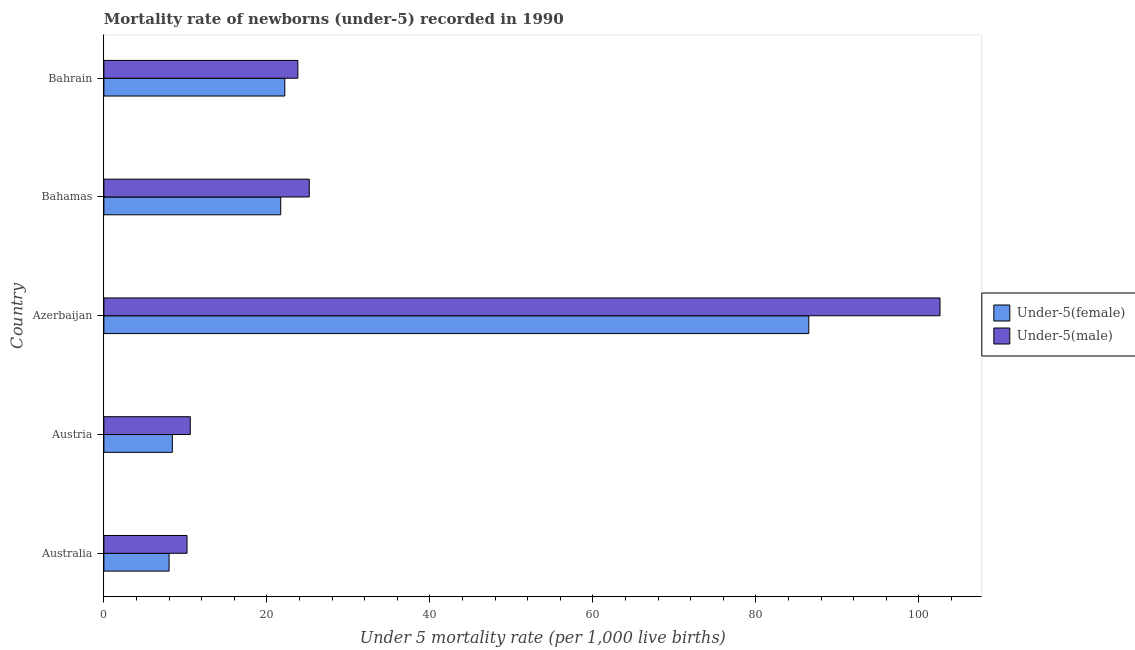How many groups of bars are there?
Provide a succinct answer. 5. Are the number of bars on each tick of the Y-axis equal?
Provide a succinct answer. Yes. How many bars are there on the 5th tick from the top?
Offer a very short reply. 2. How many bars are there on the 5th tick from the bottom?
Your answer should be very brief. 2. What is the label of the 1st group of bars from the top?
Ensure brevity in your answer.  Bahrain. In how many cases, is the number of bars for a given country not equal to the number of legend labels?
Offer a terse response. 0. What is the under-5 male mortality rate in Austria?
Ensure brevity in your answer.  10.6. Across all countries, what is the maximum under-5 female mortality rate?
Give a very brief answer. 86.5. In which country was the under-5 male mortality rate maximum?
Provide a short and direct response. Azerbaijan. In which country was the under-5 female mortality rate minimum?
Your response must be concise. Australia. What is the total under-5 male mortality rate in the graph?
Ensure brevity in your answer.  172.4. What is the difference between the under-5 male mortality rate in Austria and that in Bahamas?
Give a very brief answer. -14.6. What is the average under-5 male mortality rate per country?
Ensure brevity in your answer.  34.48. What is the ratio of the under-5 male mortality rate in Australia to that in Bahamas?
Give a very brief answer. 0.41. Is the difference between the under-5 female mortality rate in Australia and Austria greater than the difference between the under-5 male mortality rate in Australia and Austria?
Ensure brevity in your answer.  No. What is the difference between the highest and the second highest under-5 male mortality rate?
Give a very brief answer. 77.4. What is the difference between the highest and the lowest under-5 female mortality rate?
Keep it short and to the point. 78.5. Is the sum of the under-5 female mortality rate in Australia and Austria greater than the maximum under-5 male mortality rate across all countries?
Provide a succinct answer. No. What does the 2nd bar from the top in Australia represents?
Your answer should be compact. Under-5(female). What does the 2nd bar from the bottom in Bahamas represents?
Make the answer very short. Under-5(male). Are all the bars in the graph horizontal?
Your answer should be very brief. Yes. Does the graph contain any zero values?
Provide a succinct answer. No. Does the graph contain grids?
Ensure brevity in your answer.  No. How many legend labels are there?
Your answer should be very brief. 2. How are the legend labels stacked?
Provide a succinct answer. Vertical. What is the title of the graph?
Make the answer very short. Mortality rate of newborns (under-5) recorded in 1990. Does "Measles" appear as one of the legend labels in the graph?
Keep it short and to the point. No. What is the label or title of the X-axis?
Offer a terse response. Under 5 mortality rate (per 1,0 live births). What is the Under 5 mortality rate (per 1,000 live births) in Under-5(male) in Australia?
Provide a short and direct response. 10.2. What is the Under 5 mortality rate (per 1,000 live births) of Under-5(female) in Austria?
Provide a short and direct response. 8.4. What is the Under 5 mortality rate (per 1,000 live births) of Under-5(male) in Austria?
Give a very brief answer. 10.6. What is the Under 5 mortality rate (per 1,000 live births) of Under-5(female) in Azerbaijan?
Your answer should be compact. 86.5. What is the Under 5 mortality rate (per 1,000 live births) in Under-5(male) in Azerbaijan?
Provide a short and direct response. 102.6. What is the Under 5 mortality rate (per 1,000 live births) of Under-5(female) in Bahamas?
Keep it short and to the point. 21.7. What is the Under 5 mortality rate (per 1,000 live births) in Under-5(male) in Bahamas?
Provide a succinct answer. 25.2. What is the Under 5 mortality rate (per 1,000 live births) of Under-5(female) in Bahrain?
Offer a terse response. 22.2. What is the Under 5 mortality rate (per 1,000 live births) of Under-5(male) in Bahrain?
Make the answer very short. 23.8. Across all countries, what is the maximum Under 5 mortality rate (per 1,000 live births) of Under-5(female)?
Offer a terse response. 86.5. Across all countries, what is the maximum Under 5 mortality rate (per 1,000 live births) in Under-5(male)?
Your answer should be compact. 102.6. Across all countries, what is the minimum Under 5 mortality rate (per 1,000 live births) of Under-5(male)?
Keep it short and to the point. 10.2. What is the total Under 5 mortality rate (per 1,000 live births) in Under-5(female) in the graph?
Offer a very short reply. 146.8. What is the total Under 5 mortality rate (per 1,000 live births) in Under-5(male) in the graph?
Your response must be concise. 172.4. What is the difference between the Under 5 mortality rate (per 1,000 live births) in Under-5(female) in Australia and that in Austria?
Provide a short and direct response. -0.4. What is the difference between the Under 5 mortality rate (per 1,000 live births) of Under-5(female) in Australia and that in Azerbaijan?
Offer a very short reply. -78.5. What is the difference between the Under 5 mortality rate (per 1,000 live births) in Under-5(male) in Australia and that in Azerbaijan?
Your response must be concise. -92.4. What is the difference between the Under 5 mortality rate (per 1,000 live births) in Under-5(female) in Australia and that in Bahamas?
Make the answer very short. -13.7. What is the difference between the Under 5 mortality rate (per 1,000 live births) in Under-5(male) in Australia and that in Bahamas?
Provide a short and direct response. -15. What is the difference between the Under 5 mortality rate (per 1,000 live births) of Under-5(male) in Australia and that in Bahrain?
Your response must be concise. -13.6. What is the difference between the Under 5 mortality rate (per 1,000 live births) of Under-5(female) in Austria and that in Azerbaijan?
Ensure brevity in your answer.  -78.1. What is the difference between the Under 5 mortality rate (per 1,000 live births) of Under-5(male) in Austria and that in Azerbaijan?
Give a very brief answer. -92. What is the difference between the Under 5 mortality rate (per 1,000 live births) of Under-5(female) in Austria and that in Bahamas?
Offer a very short reply. -13.3. What is the difference between the Under 5 mortality rate (per 1,000 live births) in Under-5(male) in Austria and that in Bahamas?
Provide a succinct answer. -14.6. What is the difference between the Under 5 mortality rate (per 1,000 live births) in Under-5(female) in Azerbaijan and that in Bahamas?
Your answer should be compact. 64.8. What is the difference between the Under 5 mortality rate (per 1,000 live births) of Under-5(male) in Azerbaijan and that in Bahamas?
Ensure brevity in your answer.  77.4. What is the difference between the Under 5 mortality rate (per 1,000 live births) of Under-5(female) in Azerbaijan and that in Bahrain?
Provide a short and direct response. 64.3. What is the difference between the Under 5 mortality rate (per 1,000 live births) in Under-5(male) in Azerbaijan and that in Bahrain?
Offer a very short reply. 78.8. What is the difference between the Under 5 mortality rate (per 1,000 live births) of Under-5(female) in Bahamas and that in Bahrain?
Give a very brief answer. -0.5. What is the difference between the Under 5 mortality rate (per 1,000 live births) in Under-5(female) in Australia and the Under 5 mortality rate (per 1,000 live births) in Under-5(male) in Austria?
Offer a terse response. -2.6. What is the difference between the Under 5 mortality rate (per 1,000 live births) of Under-5(female) in Australia and the Under 5 mortality rate (per 1,000 live births) of Under-5(male) in Azerbaijan?
Provide a succinct answer. -94.6. What is the difference between the Under 5 mortality rate (per 1,000 live births) in Under-5(female) in Australia and the Under 5 mortality rate (per 1,000 live births) in Under-5(male) in Bahamas?
Give a very brief answer. -17.2. What is the difference between the Under 5 mortality rate (per 1,000 live births) in Under-5(female) in Australia and the Under 5 mortality rate (per 1,000 live births) in Under-5(male) in Bahrain?
Offer a terse response. -15.8. What is the difference between the Under 5 mortality rate (per 1,000 live births) of Under-5(female) in Austria and the Under 5 mortality rate (per 1,000 live births) of Under-5(male) in Azerbaijan?
Provide a succinct answer. -94.2. What is the difference between the Under 5 mortality rate (per 1,000 live births) in Under-5(female) in Austria and the Under 5 mortality rate (per 1,000 live births) in Under-5(male) in Bahamas?
Ensure brevity in your answer.  -16.8. What is the difference between the Under 5 mortality rate (per 1,000 live births) of Under-5(female) in Austria and the Under 5 mortality rate (per 1,000 live births) of Under-5(male) in Bahrain?
Ensure brevity in your answer.  -15.4. What is the difference between the Under 5 mortality rate (per 1,000 live births) in Under-5(female) in Azerbaijan and the Under 5 mortality rate (per 1,000 live births) in Under-5(male) in Bahamas?
Offer a terse response. 61.3. What is the difference between the Under 5 mortality rate (per 1,000 live births) of Under-5(female) in Azerbaijan and the Under 5 mortality rate (per 1,000 live births) of Under-5(male) in Bahrain?
Your response must be concise. 62.7. What is the difference between the Under 5 mortality rate (per 1,000 live births) in Under-5(female) in Bahamas and the Under 5 mortality rate (per 1,000 live births) in Under-5(male) in Bahrain?
Give a very brief answer. -2.1. What is the average Under 5 mortality rate (per 1,000 live births) of Under-5(female) per country?
Give a very brief answer. 29.36. What is the average Under 5 mortality rate (per 1,000 live births) of Under-5(male) per country?
Your answer should be compact. 34.48. What is the difference between the Under 5 mortality rate (per 1,000 live births) of Under-5(female) and Under 5 mortality rate (per 1,000 live births) of Under-5(male) in Azerbaijan?
Your answer should be compact. -16.1. What is the difference between the Under 5 mortality rate (per 1,000 live births) of Under-5(female) and Under 5 mortality rate (per 1,000 live births) of Under-5(male) in Bahrain?
Your response must be concise. -1.6. What is the ratio of the Under 5 mortality rate (per 1,000 live births) of Under-5(female) in Australia to that in Austria?
Provide a succinct answer. 0.95. What is the ratio of the Under 5 mortality rate (per 1,000 live births) of Under-5(male) in Australia to that in Austria?
Keep it short and to the point. 0.96. What is the ratio of the Under 5 mortality rate (per 1,000 live births) in Under-5(female) in Australia to that in Azerbaijan?
Keep it short and to the point. 0.09. What is the ratio of the Under 5 mortality rate (per 1,000 live births) in Under-5(male) in Australia to that in Azerbaijan?
Your answer should be compact. 0.1. What is the ratio of the Under 5 mortality rate (per 1,000 live births) of Under-5(female) in Australia to that in Bahamas?
Your answer should be compact. 0.37. What is the ratio of the Under 5 mortality rate (per 1,000 live births) in Under-5(male) in Australia to that in Bahamas?
Make the answer very short. 0.4. What is the ratio of the Under 5 mortality rate (per 1,000 live births) in Under-5(female) in Australia to that in Bahrain?
Keep it short and to the point. 0.36. What is the ratio of the Under 5 mortality rate (per 1,000 live births) of Under-5(male) in Australia to that in Bahrain?
Offer a terse response. 0.43. What is the ratio of the Under 5 mortality rate (per 1,000 live births) in Under-5(female) in Austria to that in Azerbaijan?
Make the answer very short. 0.1. What is the ratio of the Under 5 mortality rate (per 1,000 live births) of Under-5(male) in Austria to that in Azerbaijan?
Your answer should be very brief. 0.1. What is the ratio of the Under 5 mortality rate (per 1,000 live births) of Under-5(female) in Austria to that in Bahamas?
Provide a succinct answer. 0.39. What is the ratio of the Under 5 mortality rate (per 1,000 live births) of Under-5(male) in Austria to that in Bahamas?
Provide a short and direct response. 0.42. What is the ratio of the Under 5 mortality rate (per 1,000 live births) in Under-5(female) in Austria to that in Bahrain?
Provide a short and direct response. 0.38. What is the ratio of the Under 5 mortality rate (per 1,000 live births) in Under-5(male) in Austria to that in Bahrain?
Give a very brief answer. 0.45. What is the ratio of the Under 5 mortality rate (per 1,000 live births) of Under-5(female) in Azerbaijan to that in Bahamas?
Your answer should be compact. 3.99. What is the ratio of the Under 5 mortality rate (per 1,000 live births) of Under-5(male) in Azerbaijan to that in Bahamas?
Make the answer very short. 4.07. What is the ratio of the Under 5 mortality rate (per 1,000 live births) of Under-5(female) in Azerbaijan to that in Bahrain?
Keep it short and to the point. 3.9. What is the ratio of the Under 5 mortality rate (per 1,000 live births) in Under-5(male) in Azerbaijan to that in Bahrain?
Ensure brevity in your answer.  4.31. What is the ratio of the Under 5 mortality rate (per 1,000 live births) of Under-5(female) in Bahamas to that in Bahrain?
Offer a very short reply. 0.98. What is the ratio of the Under 5 mortality rate (per 1,000 live births) of Under-5(male) in Bahamas to that in Bahrain?
Provide a short and direct response. 1.06. What is the difference between the highest and the second highest Under 5 mortality rate (per 1,000 live births) in Under-5(female)?
Offer a terse response. 64.3. What is the difference between the highest and the second highest Under 5 mortality rate (per 1,000 live births) in Under-5(male)?
Offer a terse response. 77.4. What is the difference between the highest and the lowest Under 5 mortality rate (per 1,000 live births) of Under-5(female)?
Your answer should be compact. 78.5. What is the difference between the highest and the lowest Under 5 mortality rate (per 1,000 live births) of Under-5(male)?
Your answer should be compact. 92.4. 